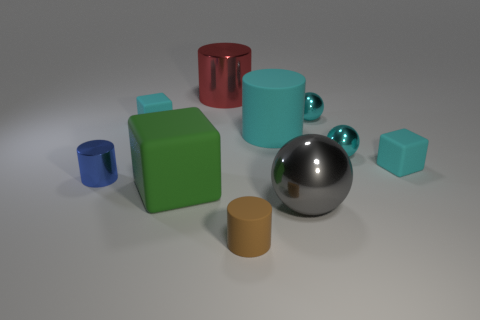Subtract 1 cylinders. How many cylinders are left? 3 Subtract all cyan cylinders. Subtract all cyan balls. How many cylinders are left? 3 Subtract all cylinders. How many objects are left? 6 Add 6 tiny blue metal cylinders. How many tiny blue metal cylinders exist? 7 Subtract 1 brown cylinders. How many objects are left? 9 Subtract all brown matte objects. Subtract all green blocks. How many objects are left? 8 Add 5 tiny cyan shiny things. How many tiny cyan shiny things are left? 7 